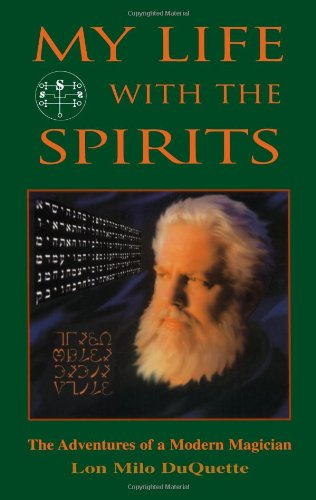Can you tell something about the symbols visible on the cover of this book? The symbols on the book cover, including the complex geometric pattern and the symbols around the border, are likely related to esoteric and magical traditions, reflecting the book's themes of occult experiences. 